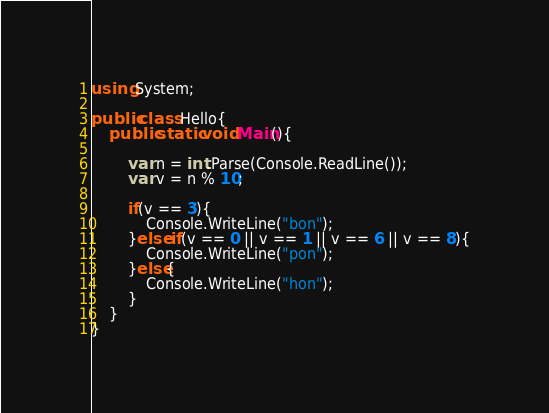Convert code to text. <code><loc_0><loc_0><loc_500><loc_500><_C#_>using System;

public class Hello{
    public static void Main(){

        var n = int.Parse(Console.ReadLine());
        var v = n % 10;
        
        if(v == 3){
            Console.WriteLine("bon");
        }else if(v == 0 || v == 1 || v == 6 || v == 8){
            Console.WriteLine("pon");
        }else{
            Console.WriteLine("hon");
        }
    }
}
</code> 